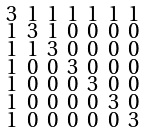Convert formula to latex. <formula><loc_0><loc_0><loc_500><loc_500>\begin{smallmatrix} 3 & 1 & 1 & 1 & 1 & 1 & 1 \\ 1 & 3 & 1 & 0 & 0 & 0 & 0 \\ 1 & 1 & 3 & 0 & 0 & 0 & 0 \\ 1 & 0 & 0 & 3 & 0 & 0 & 0 \\ 1 & 0 & 0 & 0 & 3 & 0 & 0 \\ 1 & 0 & 0 & 0 & 0 & 3 & 0 \\ 1 & 0 & 0 & 0 & 0 & 0 & 3 \end{smallmatrix}</formula> 